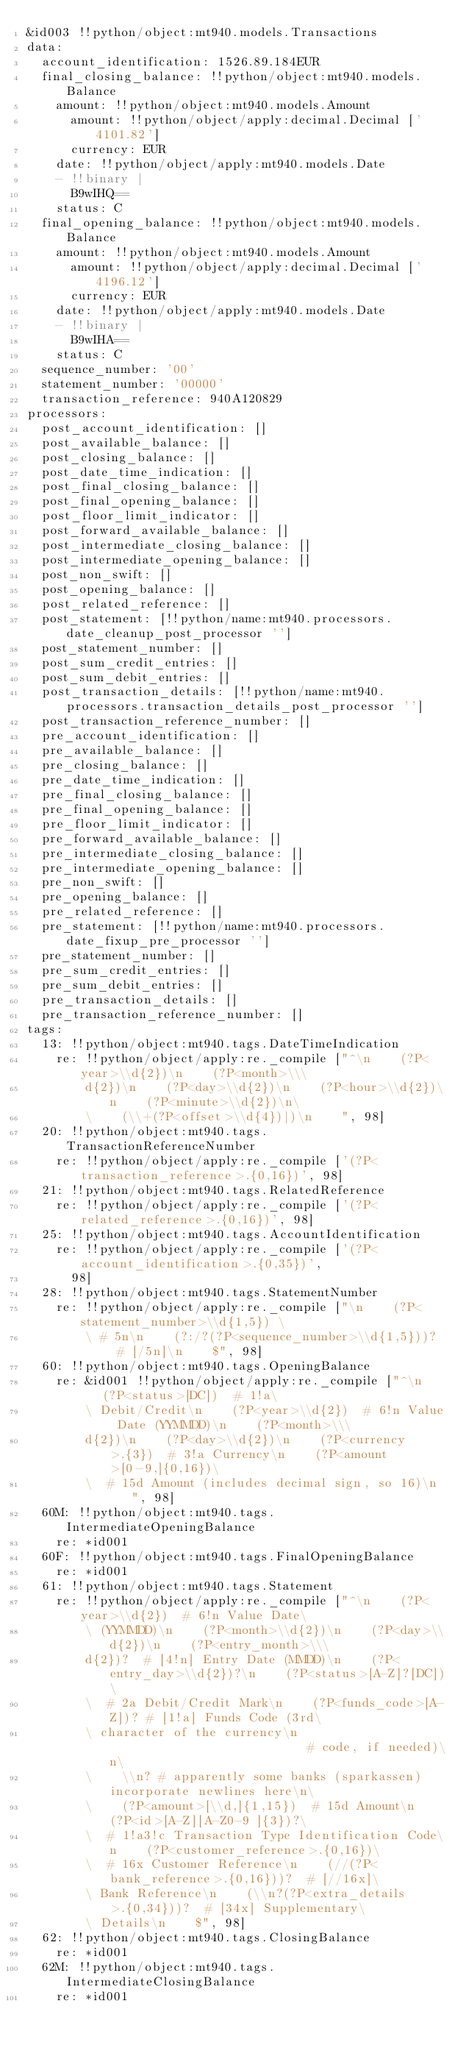<code> <loc_0><loc_0><loc_500><loc_500><_YAML_>&id003 !!python/object:mt940.models.Transactions
data:
  account_identification: 1526.89.184EUR
  final_closing_balance: !!python/object:mt940.models.Balance
    amount: !!python/object:mt940.models.Amount
      amount: !!python/object/apply:decimal.Decimal ['4101.82']
      currency: EUR
    date: !!python/object/apply:mt940.models.Date
    - !!binary |
      B9wIHQ==
    status: C
  final_opening_balance: !!python/object:mt940.models.Balance
    amount: !!python/object:mt940.models.Amount
      amount: !!python/object/apply:decimal.Decimal ['4196.12']
      currency: EUR
    date: !!python/object/apply:mt940.models.Date
    - !!binary |
      B9wIHA==
    status: C
  sequence_number: '00'
  statement_number: '00000'
  transaction_reference: 940A120829
processors:
  post_account_identification: []
  post_available_balance: []
  post_closing_balance: []
  post_date_time_indication: []
  post_final_closing_balance: []
  post_final_opening_balance: []
  post_floor_limit_indicator: []
  post_forward_available_balance: []
  post_intermediate_closing_balance: []
  post_intermediate_opening_balance: []
  post_non_swift: []
  post_opening_balance: []
  post_related_reference: []
  post_statement: [!!python/name:mt940.processors.date_cleanup_post_processor '']
  post_statement_number: []
  post_sum_credit_entries: []
  post_sum_debit_entries: []
  post_transaction_details: [!!python/name:mt940.processors.transaction_details_post_processor '']
  post_transaction_reference_number: []
  pre_account_identification: []
  pre_available_balance: []
  pre_closing_balance: []
  pre_date_time_indication: []
  pre_final_closing_balance: []
  pre_final_opening_balance: []
  pre_floor_limit_indicator: []
  pre_forward_available_balance: []
  pre_intermediate_closing_balance: []
  pre_intermediate_opening_balance: []
  pre_non_swift: []
  pre_opening_balance: []
  pre_related_reference: []
  pre_statement: [!!python/name:mt940.processors.date_fixup_pre_processor '']
  pre_statement_number: []
  pre_sum_credit_entries: []
  pre_sum_debit_entries: []
  pre_transaction_details: []
  pre_transaction_reference_number: []
tags:
  13: !!python/object:mt940.tags.DateTimeIndication
    re: !!python/object/apply:re._compile ["^\n    (?P<year>\\d{2})\n    (?P<month>\\\
        d{2})\n    (?P<day>\\d{2})\n    (?P<hour>\\d{2})\n    (?P<minute>\\d{2})\n\
        \    (\\+(?P<offset>\\d{4})|)\n    ", 98]
  20: !!python/object:mt940.tags.TransactionReferenceNumber
    re: !!python/object/apply:re._compile ['(?P<transaction_reference>.{0,16})', 98]
  21: !!python/object:mt940.tags.RelatedReference
    re: !!python/object/apply:re._compile ['(?P<related_reference>.{0,16})', 98]
  25: !!python/object:mt940.tags.AccountIdentification
    re: !!python/object/apply:re._compile ['(?P<account_identification>.{0,35})',
      98]
  28: !!python/object:mt940.tags.StatementNumber
    re: !!python/object/apply:re._compile ["\n    (?P<statement_number>\\d{1,5}) \
        \ # 5n\n    (?:/?(?P<sequence_number>\\d{1,5}))?  # [/5n]\n    $", 98]
  60: !!python/object:mt940.tags.OpeningBalance
    re: &id001 !!python/object/apply:re._compile ["^\n    (?P<status>[DC])  # 1!a\
        \ Debit/Credit\n    (?P<year>\\d{2})  # 6!n Value Date (YYMMDD)\n    (?P<month>\\\
        d{2})\n    (?P<day>\\d{2})\n    (?P<currency>.{3})  # 3!a Currency\n    (?P<amount>[0-9,]{0,16})\
        \  # 15d Amount (includes decimal sign, so 16)\n    ", 98]
  60M: !!python/object:mt940.tags.IntermediateOpeningBalance
    re: *id001
  60F: !!python/object:mt940.tags.FinalOpeningBalance
    re: *id001
  61: !!python/object:mt940.tags.Statement
    re: !!python/object/apply:re._compile ["^\n    (?P<year>\\d{2})  # 6!n Value Date\
        \ (YYMMDD)\n    (?P<month>\\d{2})\n    (?P<day>\\d{2})\n    (?P<entry_month>\\\
        d{2})?  # [4!n] Entry Date (MMDD)\n    (?P<entry_day>\\d{2})?\n    (?P<status>[A-Z]?[DC])\
        \  # 2a Debit/Credit Mark\n    (?P<funds_code>[A-Z])? # [1!a] Funds Code (3rd\
        \ character of the currency\n                            # code, if needed)\n\
        \    \\n? # apparently some banks (sparkassen) incorporate newlines here\n\
        \    (?P<amount>[\\d,]{1,15})  # 15d Amount\n    (?P<id>[A-Z][A-Z0-9 ]{3})?\
        \  # 1!a3!c Transaction Type Identification Code\n    (?P<customer_reference>.{0,16})\
        \  # 16x Customer Reference\n    (//(?P<bank_reference>.{0,16}))?  # [//16x]\
        \ Bank Reference\n    (\\n?(?P<extra_details>.{0,34}))?  # [34x] Supplementary\
        \ Details\n    $", 98]
  62: !!python/object:mt940.tags.ClosingBalance
    re: *id001
  62M: !!python/object:mt940.tags.IntermediateClosingBalance
    re: *id001</code> 